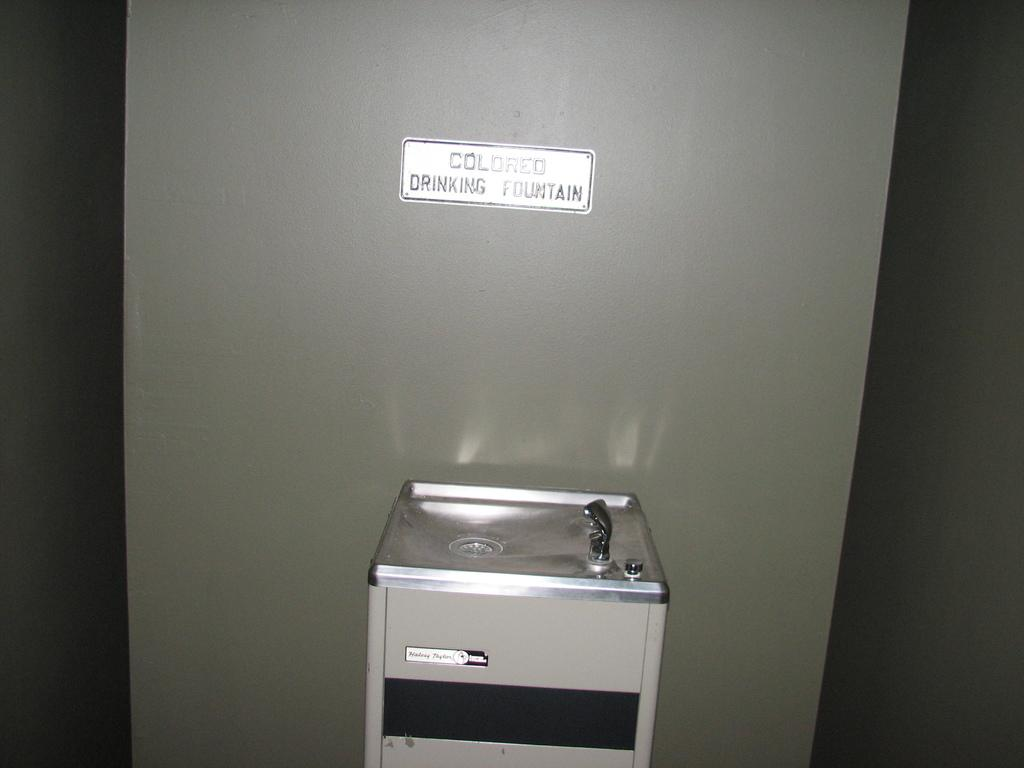<image>
Provide a brief description of the given image. A fountain with a sign saying colored drinking fountain on the wall. 